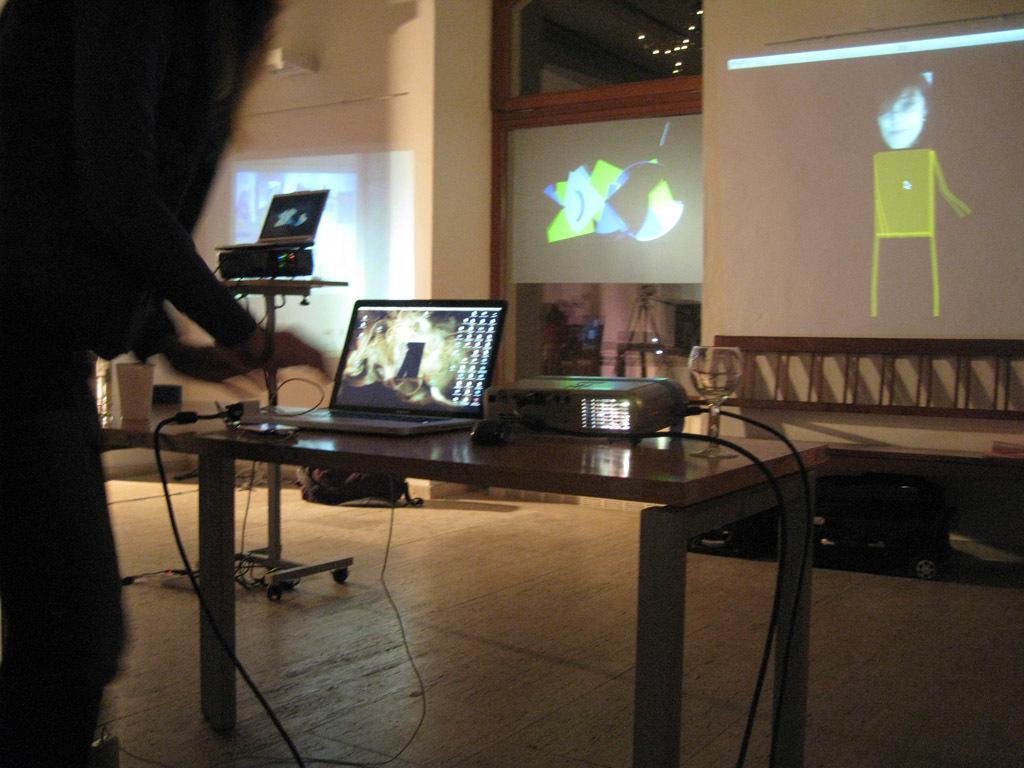Can you describe this image briefly? Here in this picture, in the front we can see a table present on the floor, on which we can see a laptop and a projector and a glass present and we can also see cable wires connected and in front of it we can see a wall, on which we can see something projected and below that we can see a ladder present and beside that also we can see a table, on which we can see a projector with a laptop present on it and in front of that also we can see something projected on the projector screen and beside that also we can see something projected on the wall and we can see lights also present on the roof. 